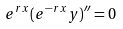<formula> <loc_0><loc_0><loc_500><loc_500>e ^ { r x } ( e ^ { - r x } y ) ^ { \prime \prime } = 0</formula> 